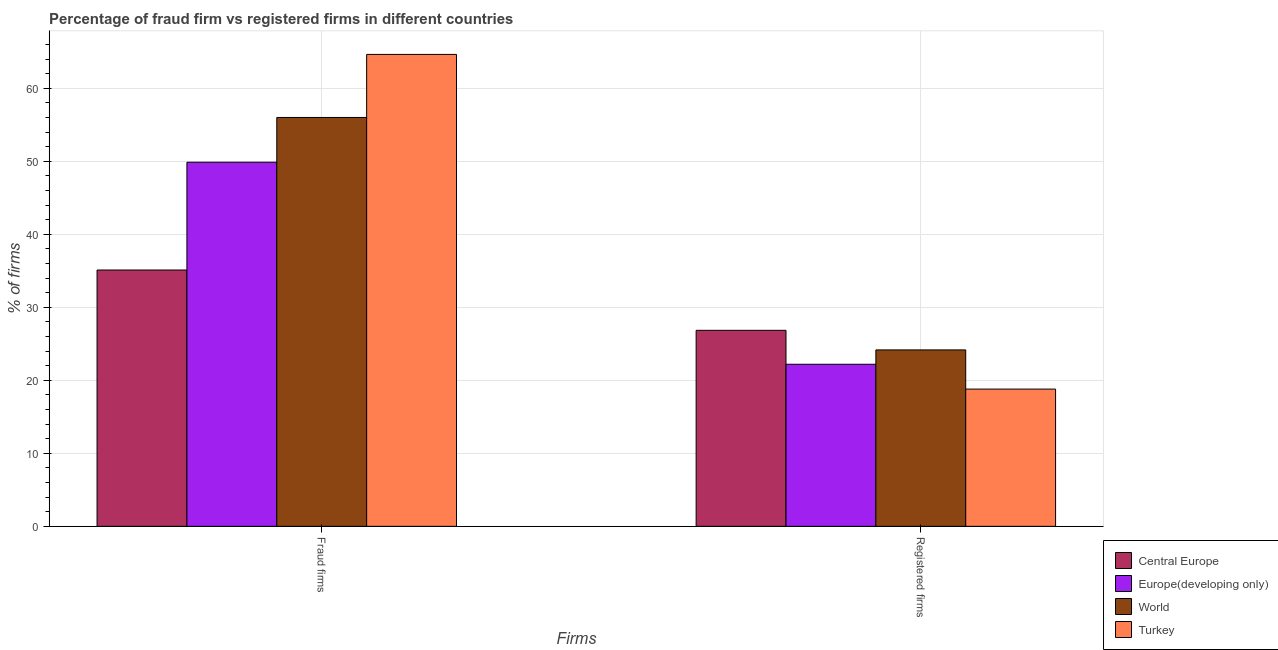How many different coloured bars are there?
Provide a short and direct response. 4. How many groups of bars are there?
Keep it short and to the point. 2. Are the number of bars on each tick of the X-axis equal?
Provide a succinct answer. Yes. What is the label of the 2nd group of bars from the left?
Keep it short and to the point. Registered firms. What is the percentage of registered firms in World?
Ensure brevity in your answer.  24.17. Across all countries, what is the maximum percentage of fraud firms?
Make the answer very short. 64.64. Across all countries, what is the minimum percentage of fraud firms?
Keep it short and to the point. 35.11. What is the total percentage of fraud firms in the graph?
Your response must be concise. 205.63. What is the difference between the percentage of fraud firms in Turkey and that in Europe(developing only)?
Ensure brevity in your answer.  14.77. What is the difference between the percentage of registered firms in World and the percentage of fraud firms in Central Europe?
Keep it short and to the point. -10.94. What is the average percentage of fraud firms per country?
Your response must be concise. 51.41. What is the difference between the percentage of registered firms and percentage of fraud firms in World?
Your answer should be compact. -31.84. What is the ratio of the percentage of registered firms in Europe(developing only) to that in Turkey?
Ensure brevity in your answer.  1.18. In how many countries, is the percentage of fraud firms greater than the average percentage of fraud firms taken over all countries?
Provide a short and direct response. 2. How many bars are there?
Ensure brevity in your answer.  8. Are all the bars in the graph horizontal?
Give a very brief answer. No. How many countries are there in the graph?
Make the answer very short. 4. What is the title of the graph?
Give a very brief answer. Percentage of fraud firm vs registered firms in different countries. Does "Paraguay" appear as one of the legend labels in the graph?
Your response must be concise. No. What is the label or title of the X-axis?
Your response must be concise. Firms. What is the label or title of the Y-axis?
Make the answer very short. % of firms. What is the % of firms of Central Europe in Fraud firms?
Offer a very short reply. 35.11. What is the % of firms of Europe(developing only) in Fraud firms?
Provide a short and direct response. 49.88. What is the % of firms in World in Fraud firms?
Ensure brevity in your answer.  56.01. What is the % of firms of Turkey in Fraud firms?
Offer a terse response. 64.64. What is the % of firms in Central Europe in Registered firms?
Ensure brevity in your answer.  26.85. What is the % of firms in World in Registered firms?
Make the answer very short. 24.17. What is the % of firms in Turkey in Registered firms?
Your answer should be compact. 18.8. Across all Firms, what is the maximum % of firms of Central Europe?
Offer a terse response. 35.11. Across all Firms, what is the maximum % of firms in Europe(developing only)?
Your response must be concise. 49.88. Across all Firms, what is the maximum % of firms of World?
Give a very brief answer. 56.01. Across all Firms, what is the maximum % of firms of Turkey?
Offer a very short reply. 64.64. Across all Firms, what is the minimum % of firms in Central Europe?
Offer a very short reply. 26.85. Across all Firms, what is the minimum % of firms in Europe(developing only)?
Your answer should be compact. 22.2. Across all Firms, what is the minimum % of firms of World?
Provide a succinct answer. 24.17. What is the total % of firms in Central Europe in the graph?
Your response must be concise. 61.96. What is the total % of firms in Europe(developing only) in the graph?
Keep it short and to the point. 72.08. What is the total % of firms of World in the graph?
Your answer should be compact. 80.17. What is the total % of firms of Turkey in the graph?
Offer a very short reply. 83.44. What is the difference between the % of firms in Central Europe in Fraud firms and that in Registered firms?
Provide a short and direct response. 8.26. What is the difference between the % of firms in Europe(developing only) in Fraud firms and that in Registered firms?
Keep it short and to the point. 27.68. What is the difference between the % of firms of World in Fraud firms and that in Registered firms?
Ensure brevity in your answer.  31.84. What is the difference between the % of firms in Turkey in Fraud firms and that in Registered firms?
Ensure brevity in your answer.  45.84. What is the difference between the % of firms in Central Europe in Fraud firms and the % of firms in Europe(developing only) in Registered firms?
Offer a terse response. 12.91. What is the difference between the % of firms of Central Europe in Fraud firms and the % of firms of World in Registered firms?
Your answer should be compact. 10.94. What is the difference between the % of firms of Central Europe in Fraud firms and the % of firms of Turkey in Registered firms?
Provide a short and direct response. 16.31. What is the difference between the % of firms in Europe(developing only) in Fraud firms and the % of firms in World in Registered firms?
Offer a terse response. 25.71. What is the difference between the % of firms of Europe(developing only) in Fraud firms and the % of firms of Turkey in Registered firms?
Offer a terse response. 31.07. What is the difference between the % of firms of World in Fraud firms and the % of firms of Turkey in Registered firms?
Provide a short and direct response. 37.2. What is the average % of firms in Central Europe per Firms?
Ensure brevity in your answer.  30.98. What is the average % of firms in Europe(developing only) per Firms?
Keep it short and to the point. 36.04. What is the average % of firms in World per Firms?
Offer a very short reply. 40.09. What is the average % of firms of Turkey per Firms?
Your answer should be very brief. 41.72. What is the difference between the % of firms in Central Europe and % of firms in Europe(developing only) in Fraud firms?
Make the answer very short. -14.77. What is the difference between the % of firms of Central Europe and % of firms of World in Fraud firms?
Provide a short and direct response. -20.89. What is the difference between the % of firms in Central Europe and % of firms in Turkey in Fraud firms?
Keep it short and to the point. -29.53. What is the difference between the % of firms of Europe(developing only) and % of firms of World in Fraud firms?
Your response must be concise. -6.13. What is the difference between the % of firms of Europe(developing only) and % of firms of Turkey in Fraud firms?
Offer a very short reply. -14.77. What is the difference between the % of firms of World and % of firms of Turkey in Fraud firms?
Your answer should be compact. -8.63. What is the difference between the % of firms of Central Europe and % of firms of Europe(developing only) in Registered firms?
Your answer should be compact. 4.65. What is the difference between the % of firms in Central Europe and % of firms in World in Registered firms?
Your response must be concise. 2.68. What is the difference between the % of firms of Central Europe and % of firms of Turkey in Registered firms?
Provide a short and direct response. 8.05. What is the difference between the % of firms of Europe(developing only) and % of firms of World in Registered firms?
Offer a terse response. -1.97. What is the difference between the % of firms in World and % of firms in Turkey in Registered firms?
Offer a very short reply. 5.37. What is the ratio of the % of firms in Central Europe in Fraud firms to that in Registered firms?
Offer a very short reply. 1.31. What is the ratio of the % of firms of Europe(developing only) in Fraud firms to that in Registered firms?
Offer a very short reply. 2.25. What is the ratio of the % of firms of World in Fraud firms to that in Registered firms?
Offer a terse response. 2.32. What is the ratio of the % of firms in Turkey in Fraud firms to that in Registered firms?
Offer a very short reply. 3.44. What is the difference between the highest and the second highest % of firms of Central Europe?
Your answer should be very brief. 8.26. What is the difference between the highest and the second highest % of firms in Europe(developing only)?
Make the answer very short. 27.68. What is the difference between the highest and the second highest % of firms of World?
Provide a short and direct response. 31.84. What is the difference between the highest and the second highest % of firms of Turkey?
Make the answer very short. 45.84. What is the difference between the highest and the lowest % of firms in Central Europe?
Provide a short and direct response. 8.26. What is the difference between the highest and the lowest % of firms of Europe(developing only)?
Keep it short and to the point. 27.68. What is the difference between the highest and the lowest % of firms of World?
Offer a very short reply. 31.84. What is the difference between the highest and the lowest % of firms in Turkey?
Offer a very short reply. 45.84. 